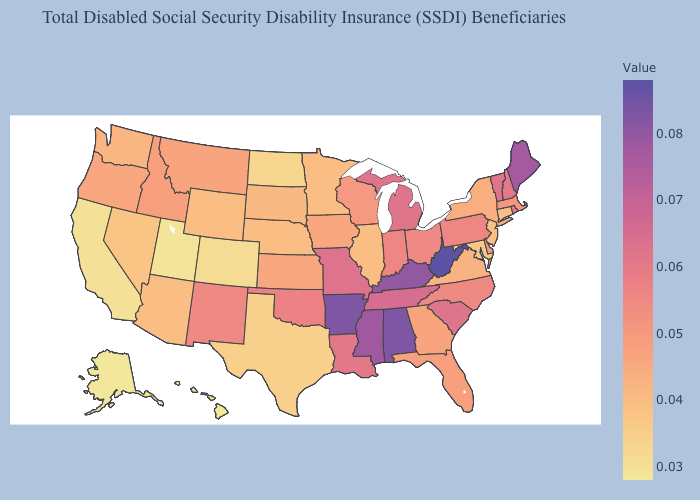Among the states that border Ohio , does West Virginia have the highest value?
Be succinct. Yes. Does the map have missing data?
Be succinct. No. Does Texas have the lowest value in the South?
Be succinct. Yes. Which states have the lowest value in the USA?
Short answer required. Alaska, Hawaii. Does Missouri have the lowest value in the MidWest?
Quick response, please. No. Among the states that border Illinois , does Iowa have the lowest value?
Short answer required. Yes. Does Mississippi have a higher value than Kansas?
Short answer required. Yes. Among the states that border Minnesota , which have the highest value?
Concise answer only. Wisconsin. Among the states that border Montana , which have the lowest value?
Keep it brief. North Dakota. Does New Hampshire have the highest value in the Northeast?
Be succinct. No. 